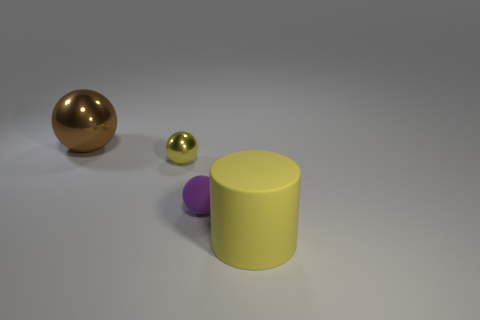There is a large metallic object; is it the same color as the rubber thing to the left of the big cylinder?
Offer a terse response. No. There is a object that is both behind the small purple ball and in front of the large sphere; how big is it?
Your answer should be very brief. Small. What number of other things are the same color as the rubber ball?
Offer a terse response. 0. How big is the thing in front of the small purple thing that is to the right of the shiny sphere to the right of the brown object?
Ensure brevity in your answer.  Large. Are there any big shiny spheres on the right side of the brown metallic sphere?
Your response must be concise. No. There is a yellow rubber thing; does it have the same size as the shiny ball that is to the right of the brown sphere?
Ensure brevity in your answer.  No. How many other objects are there of the same material as the purple thing?
Provide a succinct answer. 1. There is a thing that is both behind the purple rubber thing and in front of the brown shiny object; what is its shape?
Ensure brevity in your answer.  Sphere. There is a rubber object that is to the left of the rubber cylinder; does it have the same size as the yellow thing that is in front of the yellow shiny object?
Offer a very short reply. No. What shape is the other object that is the same material as the big brown thing?
Ensure brevity in your answer.  Sphere. 